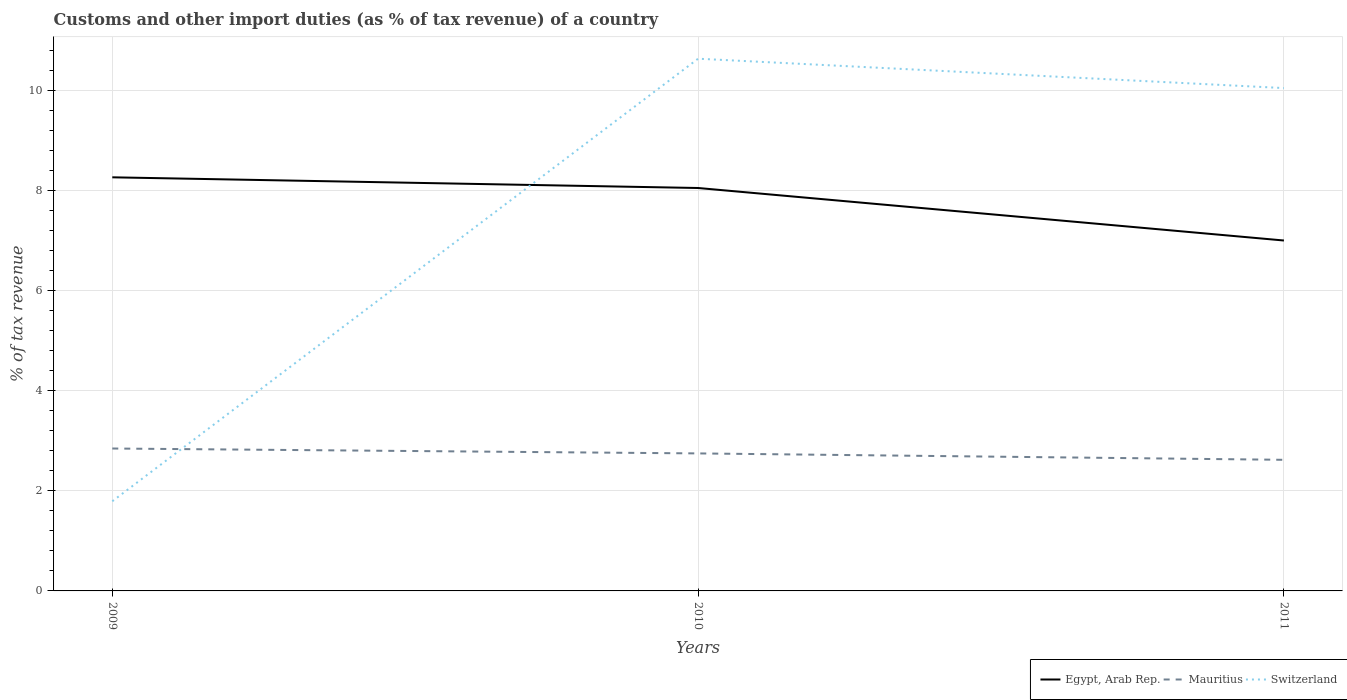Is the number of lines equal to the number of legend labels?
Your answer should be very brief. Yes. Across all years, what is the maximum percentage of tax revenue from customs in Egypt, Arab Rep.?
Your answer should be very brief. 7.01. What is the total percentage of tax revenue from customs in Switzerland in the graph?
Make the answer very short. -8.26. What is the difference between the highest and the second highest percentage of tax revenue from customs in Mauritius?
Give a very brief answer. 0.23. What is the difference between the highest and the lowest percentage of tax revenue from customs in Egypt, Arab Rep.?
Provide a short and direct response. 2. How many years are there in the graph?
Give a very brief answer. 3. Are the values on the major ticks of Y-axis written in scientific E-notation?
Make the answer very short. No. Does the graph contain grids?
Your answer should be very brief. Yes. Where does the legend appear in the graph?
Offer a terse response. Bottom right. How are the legend labels stacked?
Give a very brief answer. Horizontal. What is the title of the graph?
Keep it short and to the point. Customs and other import duties (as % of tax revenue) of a country. Does "Honduras" appear as one of the legend labels in the graph?
Your response must be concise. No. What is the label or title of the X-axis?
Keep it short and to the point. Years. What is the label or title of the Y-axis?
Make the answer very short. % of tax revenue. What is the % of tax revenue of Egypt, Arab Rep. in 2009?
Provide a succinct answer. 8.27. What is the % of tax revenue in Mauritius in 2009?
Your answer should be compact. 2.85. What is the % of tax revenue in Switzerland in 2009?
Your response must be concise. 1.79. What is the % of tax revenue of Egypt, Arab Rep. in 2010?
Your response must be concise. 8.05. What is the % of tax revenue in Mauritius in 2010?
Offer a terse response. 2.75. What is the % of tax revenue in Switzerland in 2010?
Offer a very short reply. 10.64. What is the % of tax revenue in Egypt, Arab Rep. in 2011?
Your answer should be very brief. 7.01. What is the % of tax revenue of Mauritius in 2011?
Provide a succinct answer. 2.62. What is the % of tax revenue in Switzerland in 2011?
Keep it short and to the point. 10.05. Across all years, what is the maximum % of tax revenue of Egypt, Arab Rep.?
Provide a succinct answer. 8.27. Across all years, what is the maximum % of tax revenue in Mauritius?
Provide a short and direct response. 2.85. Across all years, what is the maximum % of tax revenue of Switzerland?
Make the answer very short. 10.64. Across all years, what is the minimum % of tax revenue of Egypt, Arab Rep.?
Your answer should be very brief. 7.01. Across all years, what is the minimum % of tax revenue in Mauritius?
Your answer should be compact. 2.62. Across all years, what is the minimum % of tax revenue of Switzerland?
Provide a succinct answer. 1.79. What is the total % of tax revenue in Egypt, Arab Rep. in the graph?
Provide a succinct answer. 23.33. What is the total % of tax revenue of Mauritius in the graph?
Provide a short and direct response. 8.22. What is the total % of tax revenue of Switzerland in the graph?
Make the answer very short. 22.48. What is the difference between the % of tax revenue in Egypt, Arab Rep. in 2009 and that in 2010?
Your answer should be compact. 0.21. What is the difference between the % of tax revenue in Mauritius in 2009 and that in 2010?
Provide a short and direct response. 0.1. What is the difference between the % of tax revenue in Switzerland in 2009 and that in 2010?
Your answer should be very brief. -8.85. What is the difference between the % of tax revenue in Egypt, Arab Rep. in 2009 and that in 2011?
Ensure brevity in your answer.  1.26. What is the difference between the % of tax revenue in Mauritius in 2009 and that in 2011?
Make the answer very short. 0.23. What is the difference between the % of tax revenue of Switzerland in 2009 and that in 2011?
Offer a very short reply. -8.26. What is the difference between the % of tax revenue of Egypt, Arab Rep. in 2010 and that in 2011?
Ensure brevity in your answer.  1.05. What is the difference between the % of tax revenue of Mauritius in 2010 and that in 2011?
Give a very brief answer. 0.13. What is the difference between the % of tax revenue of Switzerland in 2010 and that in 2011?
Ensure brevity in your answer.  0.59. What is the difference between the % of tax revenue in Egypt, Arab Rep. in 2009 and the % of tax revenue in Mauritius in 2010?
Ensure brevity in your answer.  5.52. What is the difference between the % of tax revenue of Egypt, Arab Rep. in 2009 and the % of tax revenue of Switzerland in 2010?
Your answer should be compact. -2.37. What is the difference between the % of tax revenue in Mauritius in 2009 and the % of tax revenue in Switzerland in 2010?
Give a very brief answer. -7.79. What is the difference between the % of tax revenue in Egypt, Arab Rep. in 2009 and the % of tax revenue in Mauritius in 2011?
Provide a succinct answer. 5.65. What is the difference between the % of tax revenue of Egypt, Arab Rep. in 2009 and the % of tax revenue of Switzerland in 2011?
Give a very brief answer. -1.78. What is the difference between the % of tax revenue of Mauritius in 2009 and the % of tax revenue of Switzerland in 2011?
Your answer should be compact. -7.21. What is the difference between the % of tax revenue in Egypt, Arab Rep. in 2010 and the % of tax revenue in Mauritius in 2011?
Your answer should be very brief. 5.43. What is the difference between the % of tax revenue in Egypt, Arab Rep. in 2010 and the % of tax revenue in Switzerland in 2011?
Provide a succinct answer. -2. What is the difference between the % of tax revenue in Mauritius in 2010 and the % of tax revenue in Switzerland in 2011?
Make the answer very short. -7.3. What is the average % of tax revenue of Egypt, Arab Rep. per year?
Give a very brief answer. 7.78. What is the average % of tax revenue of Mauritius per year?
Ensure brevity in your answer.  2.74. What is the average % of tax revenue of Switzerland per year?
Give a very brief answer. 7.49. In the year 2009, what is the difference between the % of tax revenue in Egypt, Arab Rep. and % of tax revenue in Mauritius?
Keep it short and to the point. 5.42. In the year 2009, what is the difference between the % of tax revenue of Egypt, Arab Rep. and % of tax revenue of Switzerland?
Provide a short and direct response. 6.48. In the year 2009, what is the difference between the % of tax revenue of Mauritius and % of tax revenue of Switzerland?
Offer a terse response. 1.05. In the year 2010, what is the difference between the % of tax revenue of Egypt, Arab Rep. and % of tax revenue of Mauritius?
Ensure brevity in your answer.  5.31. In the year 2010, what is the difference between the % of tax revenue of Egypt, Arab Rep. and % of tax revenue of Switzerland?
Make the answer very short. -2.58. In the year 2010, what is the difference between the % of tax revenue of Mauritius and % of tax revenue of Switzerland?
Your answer should be compact. -7.89. In the year 2011, what is the difference between the % of tax revenue of Egypt, Arab Rep. and % of tax revenue of Mauritius?
Provide a short and direct response. 4.38. In the year 2011, what is the difference between the % of tax revenue of Egypt, Arab Rep. and % of tax revenue of Switzerland?
Offer a terse response. -3.05. In the year 2011, what is the difference between the % of tax revenue in Mauritius and % of tax revenue in Switzerland?
Make the answer very short. -7.43. What is the ratio of the % of tax revenue of Egypt, Arab Rep. in 2009 to that in 2010?
Your answer should be very brief. 1.03. What is the ratio of the % of tax revenue in Mauritius in 2009 to that in 2010?
Make the answer very short. 1.04. What is the ratio of the % of tax revenue of Switzerland in 2009 to that in 2010?
Your answer should be very brief. 0.17. What is the ratio of the % of tax revenue of Egypt, Arab Rep. in 2009 to that in 2011?
Offer a terse response. 1.18. What is the ratio of the % of tax revenue in Mauritius in 2009 to that in 2011?
Your answer should be very brief. 1.09. What is the ratio of the % of tax revenue in Switzerland in 2009 to that in 2011?
Make the answer very short. 0.18. What is the ratio of the % of tax revenue of Egypt, Arab Rep. in 2010 to that in 2011?
Your response must be concise. 1.15. What is the ratio of the % of tax revenue in Mauritius in 2010 to that in 2011?
Ensure brevity in your answer.  1.05. What is the ratio of the % of tax revenue of Switzerland in 2010 to that in 2011?
Your answer should be compact. 1.06. What is the difference between the highest and the second highest % of tax revenue of Egypt, Arab Rep.?
Keep it short and to the point. 0.21. What is the difference between the highest and the second highest % of tax revenue in Mauritius?
Your answer should be very brief. 0.1. What is the difference between the highest and the second highest % of tax revenue in Switzerland?
Your response must be concise. 0.59. What is the difference between the highest and the lowest % of tax revenue of Egypt, Arab Rep.?
Offer a terse response. 1.26. What is the difference between the highest and the lowest % of tax revenue in Mauritius?
Provide a short and direct response. 0.23. What is the difference between the highest and the lowest % of tax revenue in Switzerland?
Your response must be concise. 8.85. 